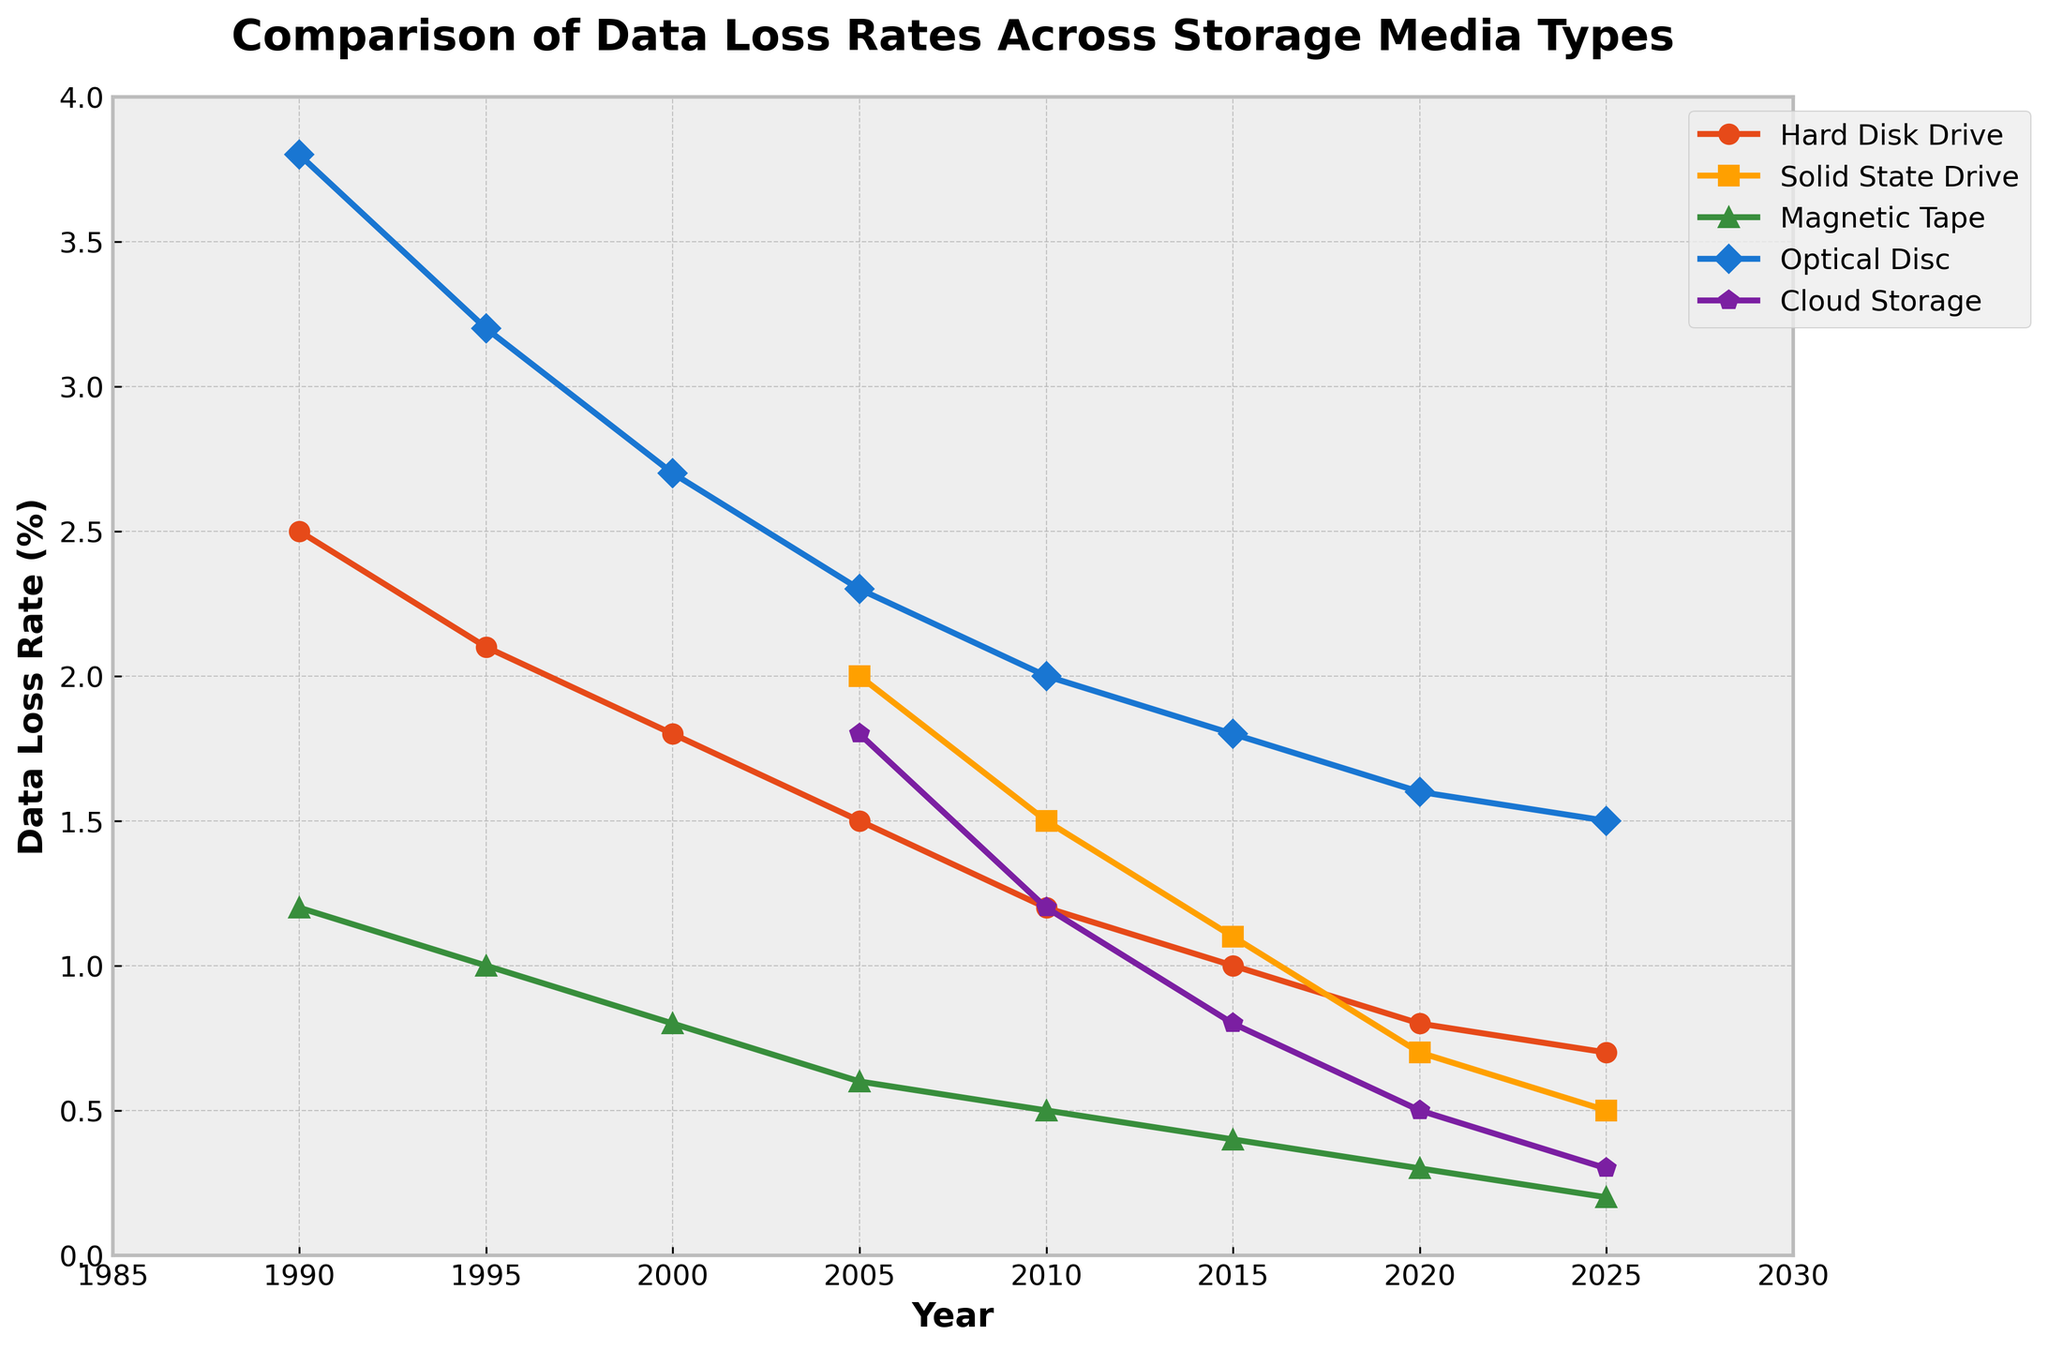Which storage medium had the highest data loss rate in 1990? In 1990, the highest line on the graph represents Optical Disc, with a data loss rate of 3.8%.
Answer: Optical Disc Which storage medium showed the greatest decrease in data loss rate from 2005 to 2025? By comparing the lines on the graph between 2005 and 2025, we see that Optical Disc showed a decrease from 2.3% to 1.5%, a drop of 0.8%, which is the greatest among all the storage media.
Answer: Optical Disc What is the difference in data loss rates between Hard Disk Drive and Solid State Drive in 2010? In 2010, the data loss rate for Hard Disk Drive is 1.2%, and for Solid State Drive, it is 1.5%. The difference is 1.5% - 1.2% = 0.3%.
Answer: 0.3% Which storage medium had the lowest data loss rate in 2025? In 2025, the line that is the lowest on the graph represents Cloud Storage, with a data loss rate of 0.3%.
Answer: Cloud Storage How does the data loss rate for Magnetic Tape compare to Cloud Storage in 2020? In 2020, the data loss rate for Magnetic Tape is 0.3%, while for Cloud Storage, it is 0.5%. Therefore, Magnetic Tape has a lower data loss rate than Cloud Storage in that year.
Answer: Lower How have the data loss rates for Hard Disk Drive changed from 1990 to 2025? The data loss rate for Hard Disk Drive decreased from 2.5% in 1990 to 0.7% in 2025.
Answer: Decreased What trend is observed in the data loss rates of Solid State Drive from 2005 to 2025? The data loss rate for Solid State Drive shows a consistent decreasing trend, going from 2.0% in 2005 to 0.5% in 2025.
Answer: Decreasing Which storage media type had a consistently decreasing data loss rate across all years considered? By examining the lines on the graph, Solid State Drive, Magnetic Tape, and Cloud Storage all show a consistently decreasing trend over the years.
Answer: Solid State Drive, Magnetic Tape, Cloud Storage 